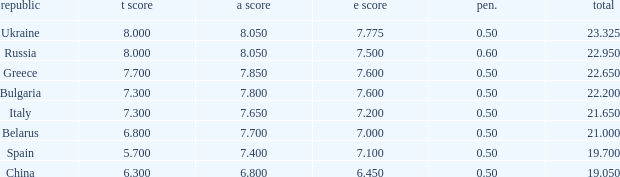What's the sum of A Score that also has a score lower than 7.3 and an E Score larger than 7.1? None. 